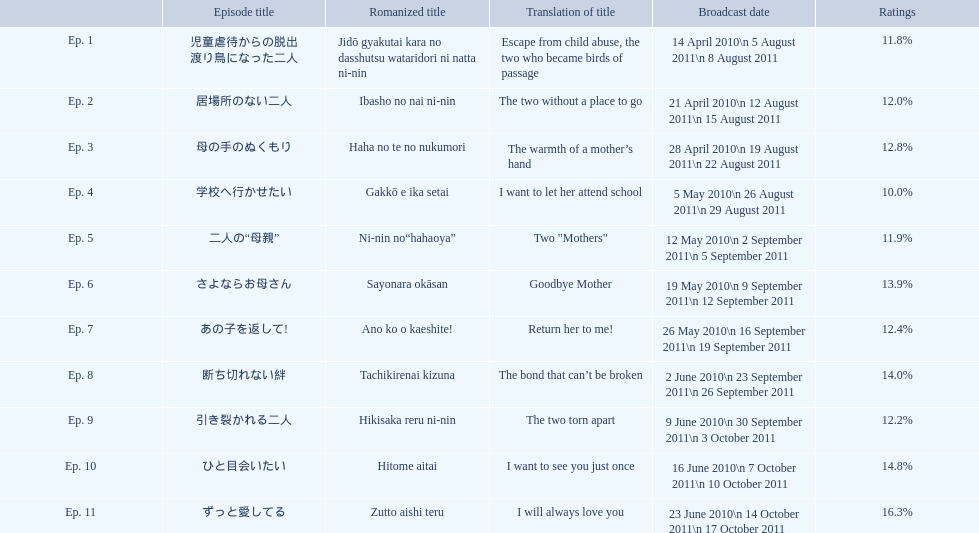Which episode received the highest viewership? Ep. 11. Which episode was titled haha no te no nukumori? Ep. 3. Apart from episode 10, which episode achieved a 14% rating? Ep. 8. 